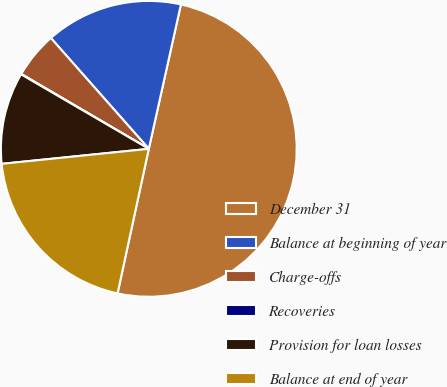<chart> <loc_0><loc_0><loc_500><loc_500><pie_chart><fcel>December 31<fcel>Balance at beginning of year<fcel>Charge-offs<fcel>Recoveries<fcel>Provision for loan losses<fcel>Balance at end of year<nl><fcel>49.9%<fcel>15.0%<fcel>5.03%<fcel>0.05%<fcel>10.02%<fcel>19.99%<nl></chart> 